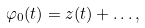<formula> <loc_0><loc_0><loc_500><loc_500>\varphi _ { 0 } ( t ) = z ( t ) + \dots ,</formula> 